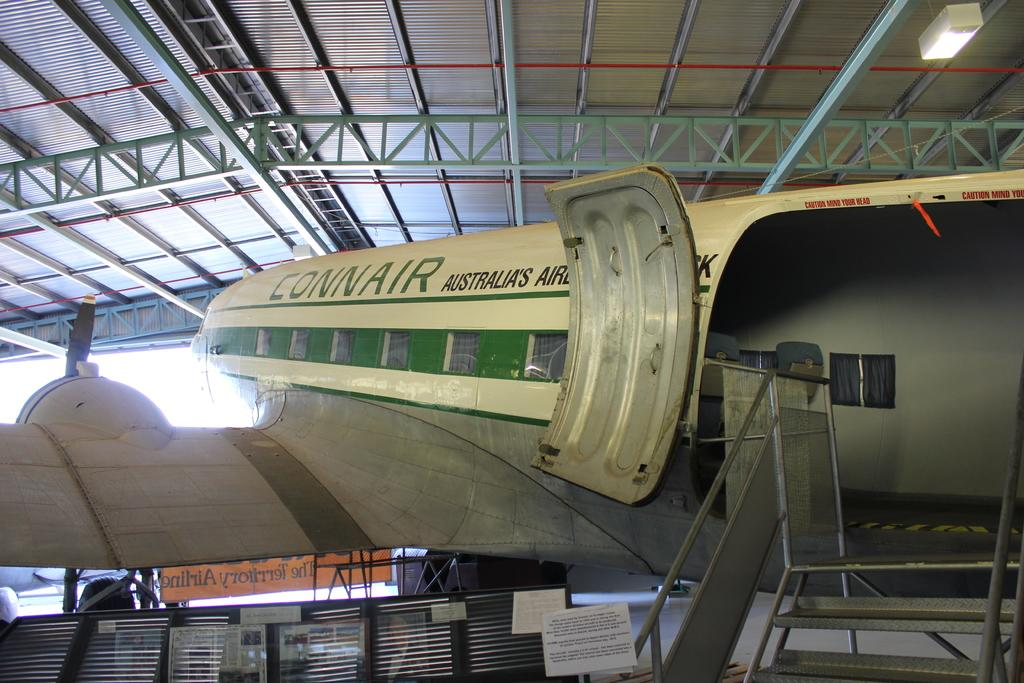<image>
Present a compact description of the photo's key features. A Connair airplane from Australia sits in an airplane hanger. 